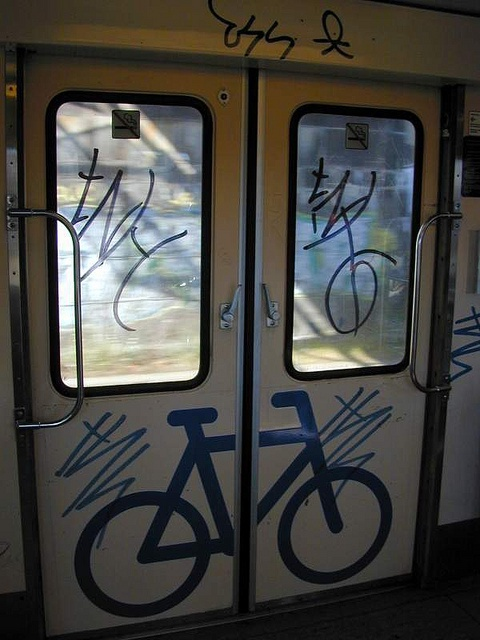Describe the objects in this image and their specific colors. I can see a train in black, gray, and darkgray tones in this image. 